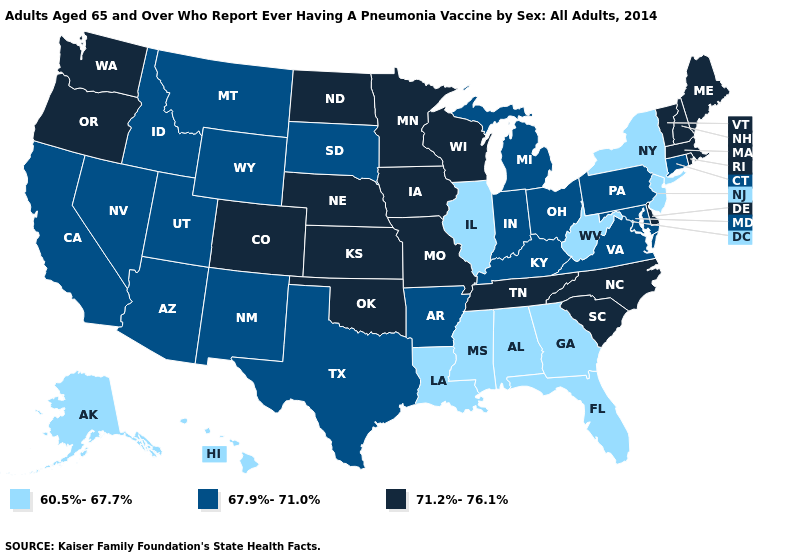Does the first symbol in the legend represent the smallest category?
Write a very short answer. Yes. Name the states that have a value in the range 60.5%-67.7%?
Short answer required. Alabama, Alaska, Florida, Georgia, Hawaii, Illinois, Louisiana, Mississippi, New Jersey, New York, West Virginia. Does Idaho have a lower value than Arizona?
Give a very brief answer. No. Among the states that border Iowa , does Missouri have the highest value?
Give a very brief answer. Yes. Name the states that have a value in the range 60.5%-67.7%?
Give a very brief answer. Alabama, Alaska, Florida, Georgia, Hawaii, Illinois, Louisiana, Mississippi, New Jersey, New York, West Virginia. Among the states that border Nebraska , which have the highest value?
Concise answer only. Colorado, Iowa, Kansas, Missouri. What is the value of Pennsylvania?
Be succinct. 67.9%-71.0%. Which states have the highest value in the USA?
Keep it brief. Colorado, Delaware, Iowa, Kansas, Maine, Massachusetts, Minnesota, Missouri, Nebraska, New Hampshire, North Carolina, North Dakota, Oklahoma, Oregon, Rhode Island, South Carolina, Tennessee, Vermont, Washington, Wisconsin. What is the lowest value in states that border Tennessee?
Short answer required. 60.5%-67.7%. Which states hav the highest value in the West?
Concise answer only. Colorado, Oregon, Washington. Which states have the highest value in the USA?
Answer briefly. Colorado, Delaware, Iowa, Kansas, Maine, Massachusetts, Minnesota, Missouri, Nebraska, New Hampshire, North Carolina, North Dakota, Oklahoma, Oregon, Rhode Island, South Carolina, Tennessee, Vermont, Washington, Wisconsin. Among the states that border Georgia , which have the lowest value?
Write a very short answer. Alabama, Florida. Name the states that have a value in the range 67.9%-71.0%?
Keep it brief. Arizona, Arkansas, California, Connecticut, Idaho, Indiana, Kentucky, Maryland, Michigan, Montana, Nevada, New Mexico, Ohio, Pennsylvania, South Dakota, Texas, Utah, Virginia, Wyoming. Name the states that have a value in the range 60.5%-67.7%?
Be succinct. Alabama, Alaska, Florida, Georgia, Hawaii, Illinois, Louisiana, Mississippi, New Jersey, New York, West Virginia. Which states have the lowest value in the West?
Concise answer only. Alaska, Hawaii. 